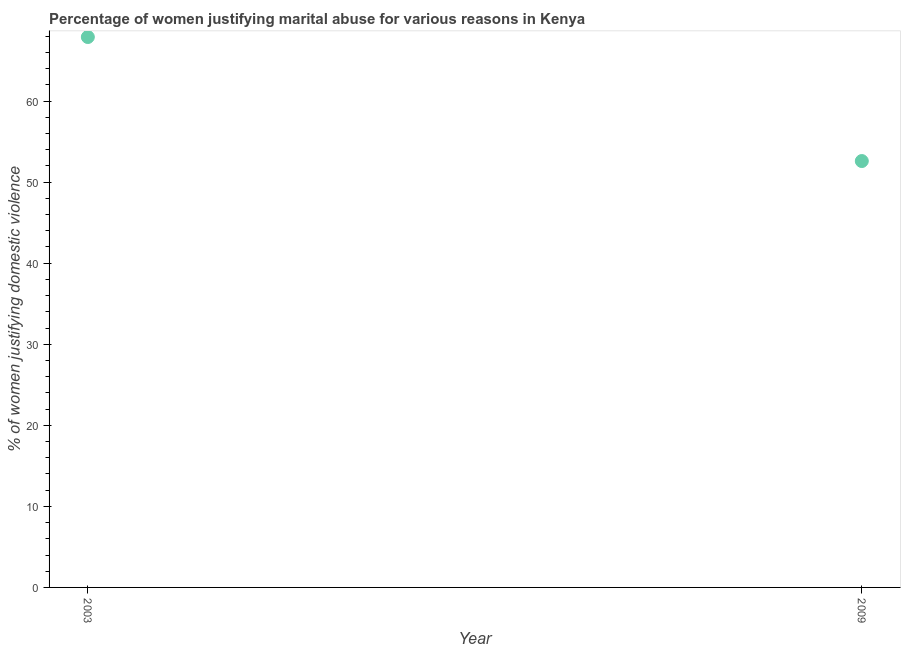What is the percentage of women justifying marital abuse in 2003?
Offer a terse response. 67.9. Across all years, what is the maximum percentage of women justifying marital abuse?
Your response must be concise. 67.9. Across all years, what is the minimum percentage of women justifying marital abuse?
Ensure brevity in your answer.  52.6. In which year was the percentage of women justifying marital abuse maximum?
Provide a succinct answer. 2003. What is the sum of the percentage of women justifying marital abuse?
Keep it short and to the point. 120.5. What is the difference between the percentage of women justifying marital abuse in 2003 and 2009?
Keep it short and to the point. 15.3. What is the average percentage of women justifying marital abuse per year?
Give a very brief answer. 60.25. What is the median percentage of women justifying marital abuse?
Ensure brevity in your answer.  60.25. Do a majority of the years between 2009 and 2003 (inclusive) have percentage of women justifying marital abuse greater than 58 %?
Your answer should be very brief. No. What is the ratio of the percentage of women justifying marital abuse in 2003 to that in 2009?
Your answer should be very brief. 1.29. Is the percentage of women justifying marital abuse in 2003 less than that in 2009?
Give a very brief answer. No. Does the percentage of women justifying marital abuse monotonically increase over the years?
Provide a short and direct response. No. How many years are there in the graph?
Keep it short and to the point. 2. Are the values on the major ticks of Y-axis written in scientific E-notation?
Ensure brevity in your answer.  No. What is the title of the graph?
Provide a succinct answer. Percentage of women justifying marital abuse for various reasons in Kenya. What is the label or title of the X-axis?
Ensure brevity in your answer.  Year. What is the label or title of the Y-axis?
Give a very brief answer. % of women justifying domestic violence. What is the % of women justifying domestic violence in 2003?
Ensure brevity in your answer.  67.9. What is the % of women justifying domestic violence in 2009?
Offer a terse response. 52.6. What is the difference between the % of women justifying domestic violence in 2003 and 2009?
Make the answer very short. 15.3. What is the ratio of the % of women justifying domestic violence in 2003 to that in 2009?
Your answer should be very brief. 1.29. 